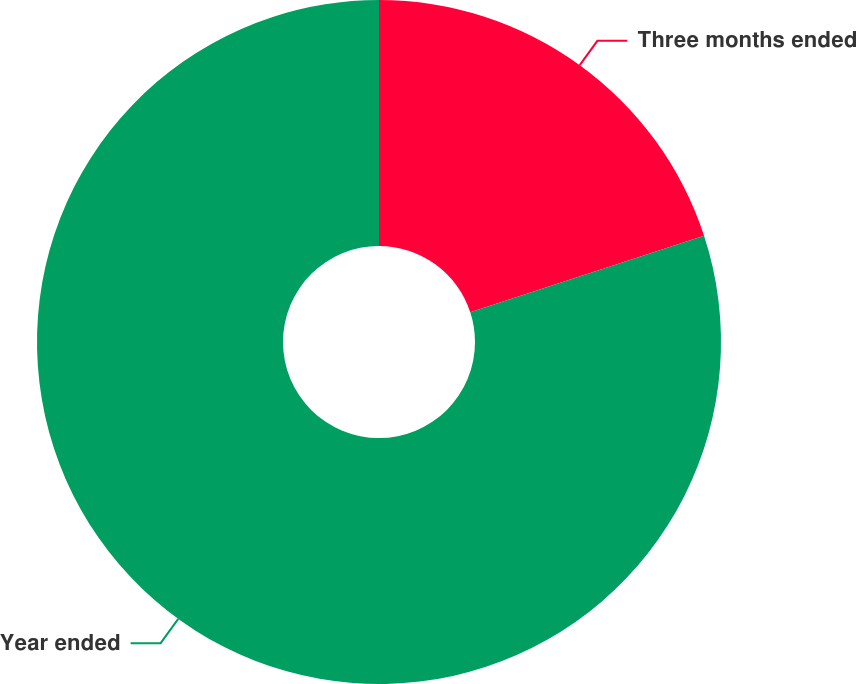Convert chart to OTSL. <chart><loc_0><loc_0><loc_500><loc_500><pie_chart><fcel>Three months ended<fcel>Year ended<nl><fcel>19.97%<fcel>80.03%<nl></chart> 